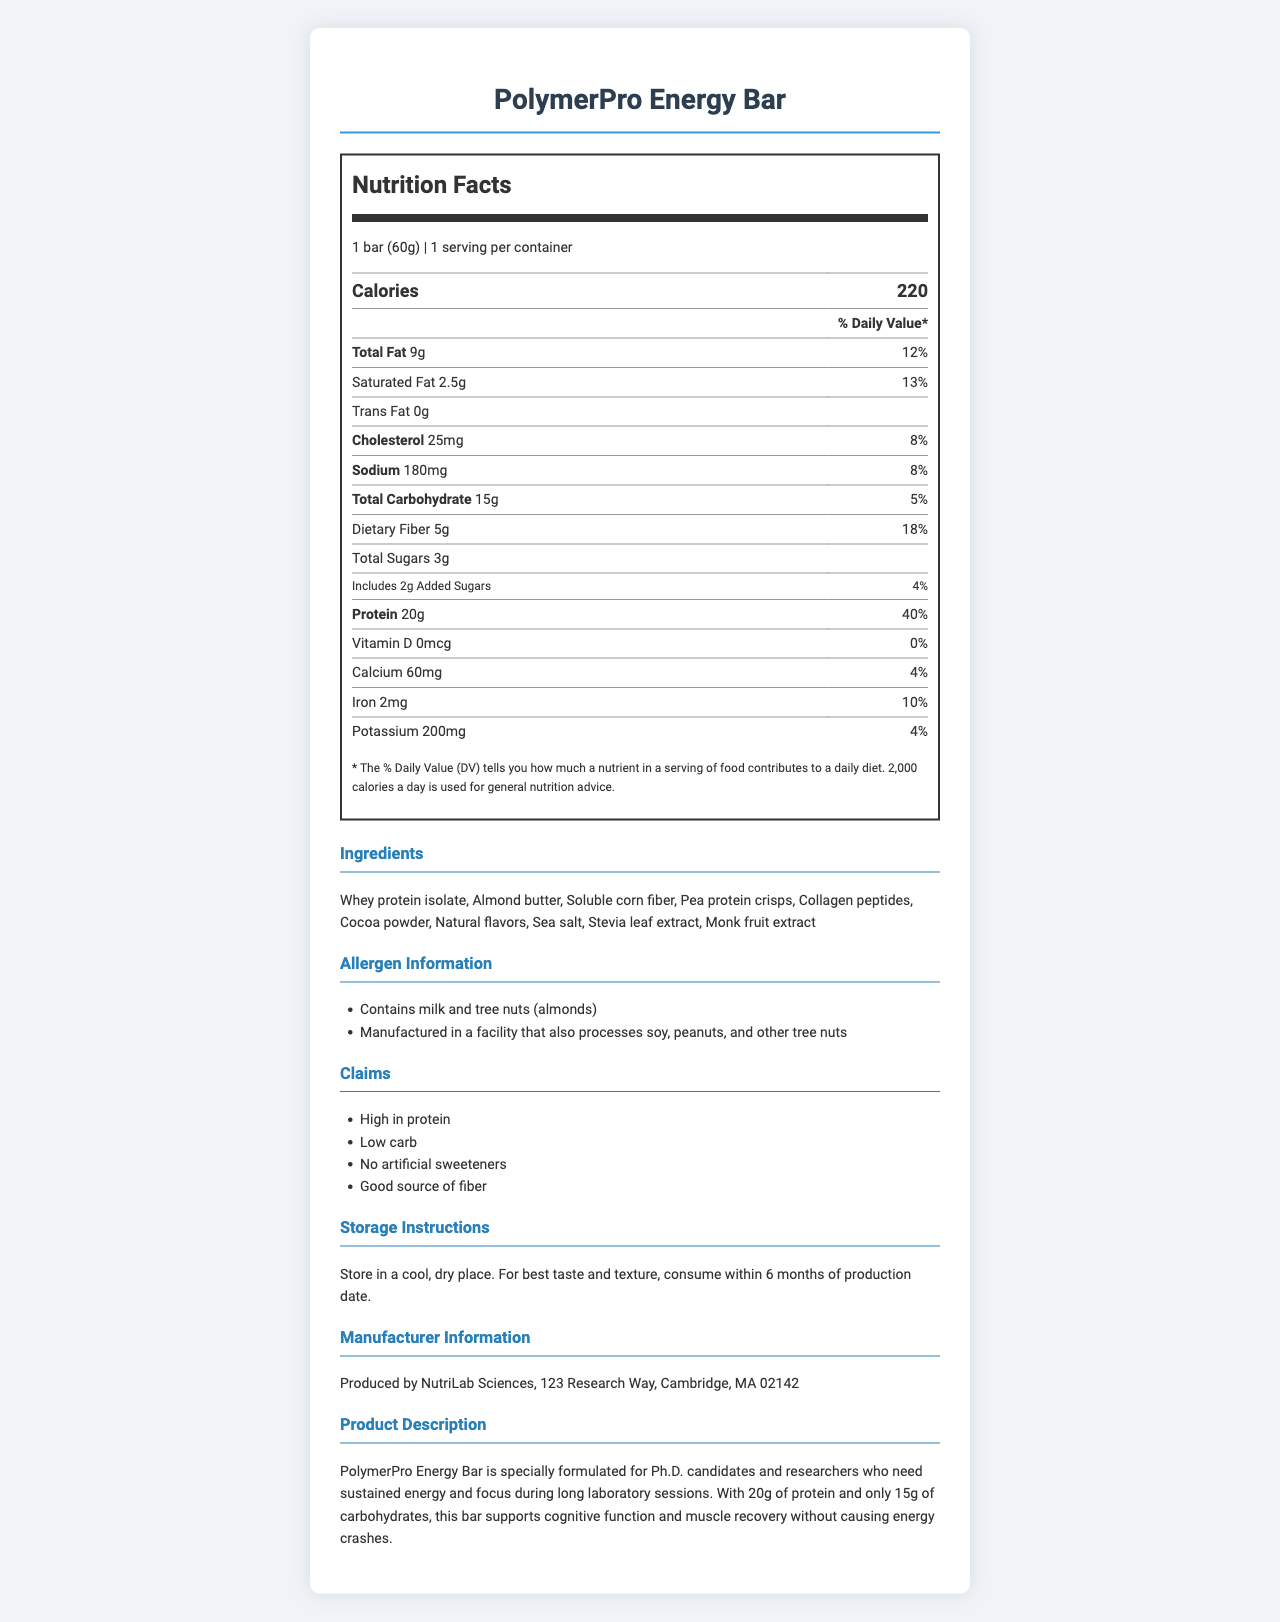what is the serving size for the PolymerPro Energy Bar? The document lists "1 bar (60g)" as the serving size.
Answer: 1 bar (60g) how many calories are in one serving of PolymerPro Energy Bar? The document specifies that there are 220 calories per serving.
Answer: 220 what percentage of the daily value of protein is provided by the PolymerPro Energy Bar? The Nutrition Facts indicate that the bar provides 20g of protein, which is 40% of the daily value.
Answer: 40% how much dietary fiber does one serving of PolymerPro Energy Bar contain? The document states that each serving contains 5g of dietary fiber, representing 18% of the daily value.
Answer: 5g how much iron is in the PolymerPro Energy Bar, and what is its daily value percentage? The document shows that the bar contains 2mg of iron, which is 10% of the daily value.
Answer: 2mg, 10% which ingredient is present in the highest amount in PolymerPro Energy Bar? A. Almond butter B. Pea protein crisps C. Whey protein isolate The first ingredient listed is Whey protein isolate, suggesting it is the primary ingredient.
Answer: C. Whey protein isolate how many grams of saturated fat are in one serving? A. 2.5g B. 9g C. 0g D. 25mg The document mentions that the bar contains 2.5g of saturated fat per serving.
Answer: A. 2.5g does the PolymerPro Energy Bar contain any added sugars? The document indicates that there are 2g of added sugars, which is 4% of the daily value.
Answer: Yes does PolymerPro Energy Bar contain vitamin D? The document lists 0mcg of vitamin D, equating to 0% of the daily value.
Answer: No summarize the purpose and nutrition focus of the PolymerPro Energy Bar. The document highlights that the PolymerPro Energy Bar is meant for sustained energy and focus during long lab sessions, providing high protein and low carbs to avoid energy crashes and aid in muscle recovery.
Answer: The PolymerPro Energy Bar is designed for Ph.D. candidates and researchers who need sustained energy and focus during long laboratory sessions. It is high in protein (20g), low in carbohydrates (15g), and aims to support cognitive function and muscle recovery without causing energy crashes. can I know the exact amount of soluble corn fiber in the bar from the provided document? The document lists "Soluble corn fiber" as an ingredient but does not specify the exact amount.
Answer: Not enough information 